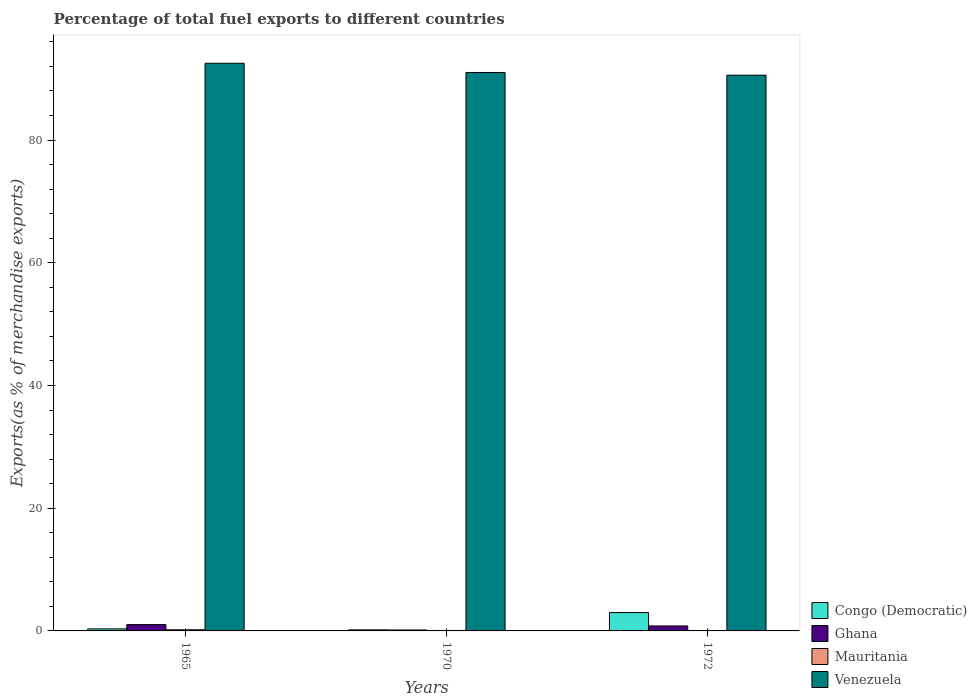How many different coloured bars are there?
Provide a short and direct response. 4. Are the number of bars per tick equal to the number of legend labels?
Keep it short and to the point. Yes. How many bars are there on the 1st tick from the left?
Give a very brief answer. 4. What is the percentage of exports to different countries in Mauritania in 1965?
Ensure brevity in your answer.  0.19. Across all years, what is the maximum percentage of exports to different countries in Mauritania?
Provide a succinct answer. 0.19. Across all years, what is the minimum percentage of exports to different countries in Congo (Democratic)?
Provide a short and direct response. 0.17. In which year was the percentage of exports to different countries in Congo (Democratic) maximum?
Provide a succinct answer. 1972. What is the total percentage of exports to different countries in Venezuela in the graph?
Ensure brevity in your answer.  274.11. What is the difference between the percentage of exports to different countries in Venezuela in 1965 and that in 1972?
Your answer should be very brief. 1.94. What is the difference between the percentage of exports to different countries in Ghana in 1970 and the percentage of exports to different countries in Congo (Democratic) in 1972?
Keep it short and to the point. -2.84. What is the average percentage of exports to different countries in Venezuela per year?
Your answer should be very brief. 91.37. In the year 1965, what is the difference between the percentage of exports to different countries in Ghana and percentage of exports to different countries in Venezuela?
Make the answer very short. -91.49. In how many years, is the percentage of exports to different countries in Venezuela greater than 52 %?
Keep it short and to the point. 3. What is the ratio of the percentage of exports to different countries in Ghana in 1970 to that in 1972?
Provide a short and direct response. 0.19. Is the percentage of exports to different countries in Mauritania in 1965 less than that in 1972?
Offer a very short reply. No. What is the difference between the highest and the second highest percentage of exports to different countries in Venezuela?
Make the answer very short. 1.5. What is the difference between the highest and the lowest percentage of exports to different countries in Mauritania?
Ensure brevity in your answer.  0.18. Is the sum of the percentage of exports to different countries in Ghana in 1970 and 1972 greater than the maximum percentage of exports to different countries in Venezuela across all years?
Offer a terse response. No. What does the 3rd bar from the left in 1972 represents?
Your response must be concise. Mauritania. What does the 4th bar from the right in 1972 represents?
Make the answer very short. Congo (Democratic). Are all the bars in the graph horizontal?
Ensure brevity in your answer.  No. How many years are there in the graph?
Your response must be concise. 3. What is the difference between two consecutive major ticks on the Y-axis?
Give a very brief answer. 20. Are the values on the major ticks of Y-axis written in scientific E-notation?
Your answer should be very brief. No. Does the graph contain any zero values?
Make the answer very short. No. Does the graph contain grids?
Your response must be concise. No. Where does the legend appear in the graph?
Offer a terse response. Bottom right. How many legend labels are there?
Offer a very short reply. 4. How are the legend labels stacked?
Provide a short and direct response. Vertical. What is the title of the graph?
Make the answer very short. Percentage of total fuel exports to different countries. Does "Finland" appear as one of the legend labels in the graph?
Your answer should be very brief. No. What is the label or title of the X-axis?
Offer a terse response. Years. What is the label or title of the Y-axis?
Your answer should be compact. Exports(as % of merchandise exports). What is the Exports(as % of merchandise exports) of Congo (Democratic) in 1965?
Give a very brief answer. 0.33. What is the Exports(as % of merchandise exports) of Ghana in 1965?
Make the answer very short. 1.03. What is the Exports(as % of merchandise exports) in Mauritania in 1965?
Make the answer very short. 0.19. What is the Exports(as % of merchandise exports) in Venezuela in 1965?
Your answer should be compact. 92.52. What is the Exports(as % of merchandise exports) of Congo (Democratic) in 1970?
Offer a very short reply. 0.17. What is the Exports(as % of merchandise exports) in Ghana in 1970?
Offer a terse response. 0.15. What is the Exports(as % of merchandise exports) of Mauritania in 1970?
Give a very brief answer. 0.07. What is the Exports(as % of merchandise exports) of Venezuela in 1970?
Offer a very short reply. 91.02. What is the Exports(as % of merchandise exports) in Congo (Democratic) in 1972?
Provide a short and direct response. 2.99. What is the Exports(as % of merchandise exports) of Ghana in 1972?
Your answer should be very brief. 0.81. What is the Exports(as % of merchandise exports) of Mauritania in 1972?
Provide a succinct answer. 0. What is the Exports(as % of merchandise exports) in Venezuela in 1972?
Provide a succinct answer. 90.57. Across all years, what is the maximum Exports(as % of merchandise exports) of Congo (Democratic)?
Ensure brevity in your answer.  2.99. Across all years, what is the maximum Exports(as % of merchandise exports) of Ghana?
Your response must be concise. 1.03. Across all years, what is the maximum Exports(as % of merchandise exports) of Mauritania?
Keep it short and to the point. 0.19. Across all years, what is the maximum Exports(as % of merchandise exports) in Venezuela?
Your answer should be very brief. 92.52. Across all years, what is the minimum Exports(as % of merchandise exports) in Congo (Democratic)?
Your answer should be compact. 0.17. Across all years, what is the minimum Exports(as % of merchandise exports) in Ghana?
Keep it short and to the point. 0.15. Across all years, what is the minimum Exports(as % of merchandise exports) of Mauritania?
Offer a terse response. 0. Across all years, what is the minimum Exports(as % of merchandise exports) in Venezuela?
Offer a terse response. 90.57. What is the total Exports(as % of merchandise exports) in Congo (Democratic) in the graph?
Give a very brief answer. 3.49. What is the total Exports(as % of merchandise exports) of Ghana in the graph?
Your answer should be compact. 1.99. What is the total Exports(as % of merchandise exports) of Mauritania in the graph?
Your answer should be compact. 0.26. What is the total Exports(as % of merchandise exports) in Venezuela in the graph?
Make the answer very short. 274.11. What is the difference between the Exports(as % of merchandise exports) in Congo (Democratic) in 1965 and that in 1970?
Your response must be concise. 0.16. What is the difference between the Exports(as % of merchandise exports) of Ghana in 1965 and that in 1970?
Keep it short and to the point. 0.88. What is the difference between the Exports(as % of merchandise exports) of Mauritania in 1965 and that in 1970?
Keep it short and to the point. 0.11. What is the difference between the Exports(as % of merchandise exports) of Venezuela in 1965 and that in 1970?
Provide a succinct answer. 1.5. What is the difference between the Exports(as % of merchandise exports) of Congo (Democratic) in 1965 and that in 1972?
Provide a short and direct response. -2.66. What is the difference between the Exports(as % of merchandise exports) of Ghana in 1965 and that in 1972?
Your answer should be very brief. 0.22. What is the difference between the Exports(as % of merchandise exports) of Mauritania in 1965 and that in 1972?
Ensure brevity in your answer.  0.18. What is the difference between the Exports(as % of merchandise exports) in Venezuela in 1965 and that in 1972?
Ensure brevity in your answer.  1.94. What is the difference between the Exports(as % of merchandise exports) in Congo (Democratic) in 1970 and that in 1972?
Provide a succinct answer. -2.81. What is the difference between the Exports(as % of merchandise exports) in Ghana in 1970 and that in 1972?
Offer a terse response. -0.65. What is the difference between the Exports(as % of merchandise exports) in Mauritania in 1970 and that in 1972?
Make the answer very short. 0.07. What is the difference between the Exports(as % of merchandise exports) in Venezuela in 1970 and that in 1972?
Provide a succinct answer. 0.44. What is the difference between the Exports(as % of merchandise exports) of Congo (Democratic) in 1965 and the Exports(as % of merchandise exports) of Ghana in 1970?
Keep it short and to the point. 0.18. What is the difference between the Exports(as % of merchandise exports) in Congo (Democratic) in 1965 and the Exports(as % of merchandise exports) in Mauritania in 1970?
Offer a terse response. 0.26. What is the difference between the Exports(as % of merchandise exports) in Congo (Democratic) in 1965 and the Exports(as % of merchandise exports) in Venezuela in 1970?
Make the answer very short. -90.69. What is the difference between the Exports(as % of merchandise exports) of Ghana in 1965 and the Exports(as % of merchandise exports) of Mauritania in 1970?
Provide a short and direct response. 0.95. What is the difference between the Exports(as % of merchandise exports) in Ghana in 1965 and the Exports(as % of merchandise exports) in Venezuela in 1970?
Provide a short and direct response. -89.99. What is the difference between the Exports(as % of merchandise exports) of Mauritania in 1965 and the Exports(as % of merchandise exports) of Venezuela in 1970?
Provide a short and direct response. -90.83. What is the difference between the Exports(as % of merchandise exports) in Congo (Democratic) in 1965 and the Exports(as % of merchandise exports) in Ghana in 1972?
Provide a succinct answer. -0.48. What is the difference between the Exports(as % of merchandise exports) in Congo (Democratic) in 1965 and the Exports(as % of merchandise exports) in Mauritania in 1972?
Your answer should be compact. 0.33. What is the difference between the Exports(as % of merchandise exports) of Congo (Democratic) in 1965 and the Exports(as % of merchandise exports) of Venezuela in 1972?
Offer a very short reply. -90.24. What is the difference between the Exports(as % of merchandise exports) in Ghana in 1965 and the Exports(as % of merchandise exports) in Mauritania in 1972?
Your response must be concise. 1.03. What is the difference between the Exports(as % of merchandise exports) in Ghana in 1965 and the Exports(as % of merchandise exports) in Venezuela in 1972?
Offer a very short reply. -89.54. What is the difference between the Exports(as % of merchandise exports) in Mauritania in 1965 and the Exports(as % of merchandise exports) in Venezuela in 1972?
Offer a very short reply. -90.39. What is the difference between the Exports(as % of merchandise exports) of Congo (Democratic) in 1970 and the Exports(as % of merchandise exports) of Ghana in 1972?
Offer a terse response. -0.63. What is the difference between the Exports(as % of merchandise exports) of Congo (Democratic) in 1970 and the Exports(as % of merchandise exports) of Mauritania in 1972?
Your response must be concise. 0.17. What is the difference between the Exports(as % of merchandise exports) of Congo (Democratic) in 1970 and the Exports(as % of merchandise exports) of Venezuela in 1972?
Offer a terse response. -90.4. What is the difference between the Exports(as % of merchandise exports) of Ghana in 1970 and the Exports(as % of merchandise exports) of Mauritania in 1972?
Make the answer very short. 0.15. What is the difference between the Exports(as % of merchandise exports) in Ghana in 1970 and the Exports(as % of merchandise exports) in Venezuela in 1972?
Give a very brief answer. -90.42. What is the difference between the Exports(as % of merchandise exports) in Mauritania in 1970 and the Exports(as % of merchandise exports) in Venezuela in 1972?
Provide a short and direct response. -90.5. What is the average Exports(as % of merchandise exports) of Congo (Democratic) per year?
Ensure brevity in your answer.  1.16. What is the average Exports(as % of merchandise exports) of Ghana per year?
Provide a succinct answer. 0.66. What is the average Exports(as % of merchandise exports) of Mauritania per year?
Provide a succinct answer. 0.09. What is the average Exports(as % of merchandise exports) of Venezuela per year?
Give a very brief answer. 91.37. In the year 1965, what is the difference between the Exports(as % of merchandise exports) in Congo (Democratic) and Exports(as % of merchandise exports) in Ghana?
Offer a very short reply. -0.7. In the year 1965, what is the difference between the Exports(as % of merchandise exports) of Congo (Democratic) and Exports(as % of merchandise exports) of Mauritania?
Keep it short and to the point. 0.14. In the year 1965, what is the difference between the Exports(as % of merchandise exports) in Congo (Democratic) and Exports(as % of merchandise exports) in Venezuela?
Your response must be concise. -92.19. In the year 1965, what is the difference between the Exports(as % of merchandise exports) of Ghana and Exports(as % of merchandise exports) of Mauritania?
Your answer should be compact. 0.84. In the year 1965, what is the difference between the Exports(as % of merchandise exports) of Ghana and Exports(as % of merchandise exports) of Venezuela?
Provide a succinct answer. -91.49. In the year 1965, what is the difference between the Exports(as % of merchandise exports) of Mauritania and Exports(as % of merchandise exports) of Venezuela?
Keep it short and to the point. -92.33. In the year 1970, what is the difference between the Exports(as % of merchandise exports) of Congo (Democratic) and Exports(as % of merchandise exports) of Ghana?
Provide a succinct answer. 0.02. In the year 1970, what is the difference between the Exports(as % of merchandise exports) of Congo (Democratic) and Exports(as % of merchandise exports) of Mauritania?
Offer a very short reply. 0.1. In the year 1970, what is the difference between the Exports(as % of merchandise exports) in Congo (Democratic) and Exports(as % of merchandise exports) in Venezuela?
Ensure brevity in your answer.  -90.84. In the year 1970, what is the difference between the Exports(as % of merchandise exports) of Ghana and Exports(as % of merchandise exports) of Mauritania?
Your answer should be very brief. 0.08. In the year 1970, what is the difference between the Exports(as % of merchandise exports) of Ghana and Exports(as % of merchandise exports) of Venezuela?
Keep it short and to the point. -90.86. In the year 1970, what is the difference between the Exports(as % of merchandise exports) of Mauritania and Exports(as % of merchandise exports) of Venezuela?
Ensure brevity in your answer.  -90.94. In the year 1972, what is the difference between the Exports(as % of merchandise exports) in Congo (Democratic) and Exports(as % of merchandise exports) in Ghana?
Make the answer very short. 2.18. In the year 1972, what is the difference between the Exports(as % of merchandise exports) in Congo (Democratic) and Exports(as % of merchandise exports) in Mauritania?
Ensure brevity in your answer.  2.99. In the year 1972, what is the difference between the Exports(as % of merchandise exports) of Congo (Democratic) and Exports(as % of merchandise exports) of Venezuela?
Keep it short and to the point. -87.59. In the year 1972, what is the difference between the Exports(as % of merchandise exports) of Ghana and Exports(as % of merchandise exports) of Mauritania?
Give a very brief answer. 0.8. In the year 1972, what is the difference between the Exports(as % of merchandise exports) in Ghana and Exports(as % of merchandise exports) in Venezuela?
Offer a terse response. -89.77. In the year 1972, what is the difference between the Exports(as % of merchandise exports) of Mauritania and Exports(as % of merchandise exports) of Venezuela?
Make the answer very short. -90.57. What is the ratio of the Exports(as % of merchandise exports) in Congo (Democratic) in 1965 to that in 1970?
Keep it short and to the point. 1.89. What is the ratio of the Exports(as % of merchandise exports) of Ghana in 1965 to that in 1970?
Give a very brief answer. 6.7. What is the ratio of the Exports(as % of merchandise exports) in Mauritania in 1965 to that in 1970?
Offer a very short reply. 2.47. What is the ratio of the Exports(as % of merchandise exports) in Venezuela in 1965 to that in 1970?
Ensure brevity in your answer.  1.02. What is the ratio of the Exports(as % of merchandise exports) in Congo (Democratic) in 1965 to that in 1972?
Keep it short and to the point. 0.11. What is the ratio of the Exports(as % of merchandise exports) in Ghana in 1965 to that in 1972?
Give a very brief answer. 1.27. What is the ratio of the Exports(as % of merchandise exports) of Mauritania in 1965 to that in 1972?
Make the answer very short. 62.35. What is the ratio of the Exports(as % of merchandise exports) of Venezuela in 1965 to that in 1972?
Provide a short and direct response. 1.02. What is the ratio of the Exports(as % of merchandise exports) in Congo (Democratic) in 1970 to that in 1972?
Ensure brevity in your answer.  0.06. What is the ratio of the Exports(as % of merchandise exports) of Ghana in 1970 to that in 1972?
Make the answer very short. 0.19. What is the ratio of the Exports(as % of merchandise exports) of Mauritania in 1970 to that in 1972?
Keep it short and to the point. 25.25. What is the ratio of the Exports(as % of merchandise exports) of Venezuela in 1970 to that in 1972?
Your response must be concise. 1. What is the difference between the highest and the second highest Exports(as % of merchandise exports) in Congo (Democratic)?
Offer a very short reply. 2.66. What is the difference between the highest and the second highest Exports(as % of merchandise exports) in Ghana?
Offer a very short reply. 0.22. What is the difference between the highest and the second highest Exports(as % of merchandise exports) in Mauritania?
Give a very brief answer. 0.11. What is the difference between the highest and the second highest Exports(as % of merchandise exports) of Venezuela?
Keep it short and to the point. 1.5. What is the difference between the highest and the lowest Exports(as % of merchandise exports) of Congo (Democratic)?
Your answer should be very brief. 2.81. What is the difference between the highest and the lowest Exports(as % of merchandise exports) of Ghana?
Provide a succinct answer. 0.88. What is the difference between the highest and the lowest Exports(as % of merchandise exports) in Mauritania?
Your answer should be compact. 0.18. What is the difference between the highest and the lowest Exports(as % of merchandise exports) of Venezuela?
Keep it short and to the point. 1.94. 